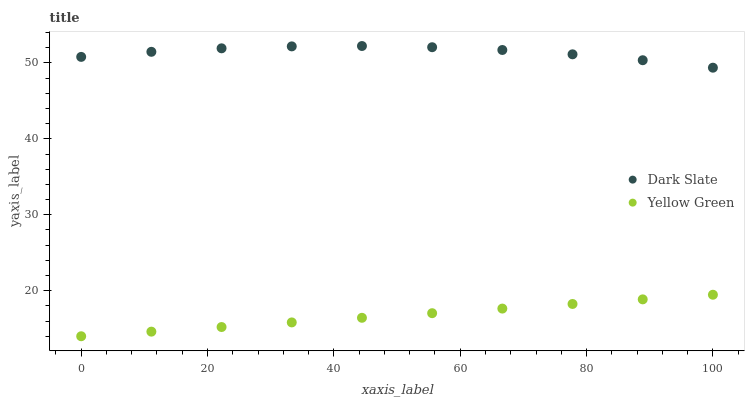Does Yellow Green have the minimum area under the curve?
Answer yes or no. Yes. Does Dark Slate have the maximum area under the curve?
Answer yes or no. Yes. Does Yellow Green have the maximum area under the curve?
Answer yes or no. No. Is Yellow Green the smoothest?
Answer yes or no. Yes. Is Dark Slate the roughest?
Answer yes or no. Yes. Is Yellow Green the roughest?
Answer yes or no. No. Does Yellow Green have the lowest value?
Answer yes or no. Yes. Does Dark Slate have the highest value?
Answer yes or no. Yes. Does Yellow Green have the highest value?
Answer yes or no. No. Is Yellow Green less than Dark Slate?
Answer yes or no. Yes. Is Dark Slate greater than Yellow Green?
Answer yes or no. Yes. Does Yellow Green intersect Dark Slate?
Answer yes or no. No. 